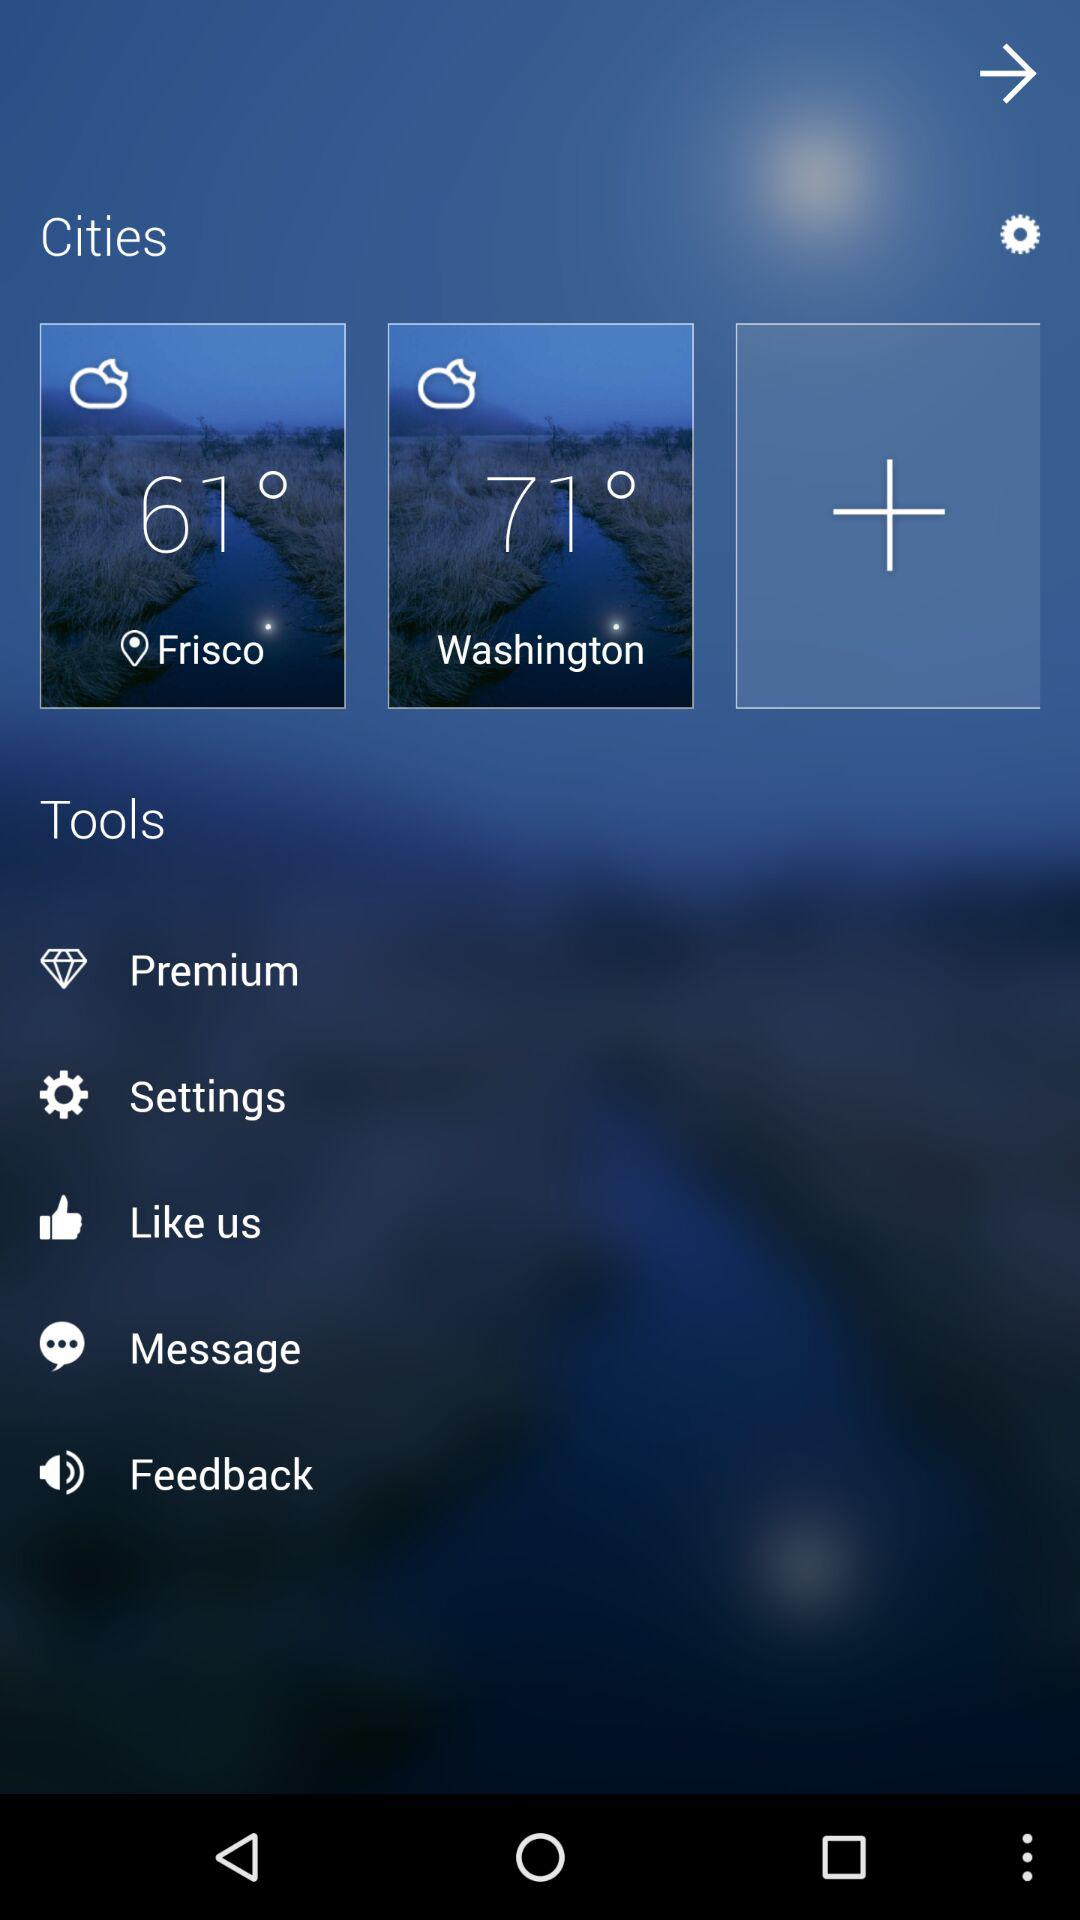How many degrees warmer is Washington than Frisco?
Answer the question using a single word or phrase. 10 